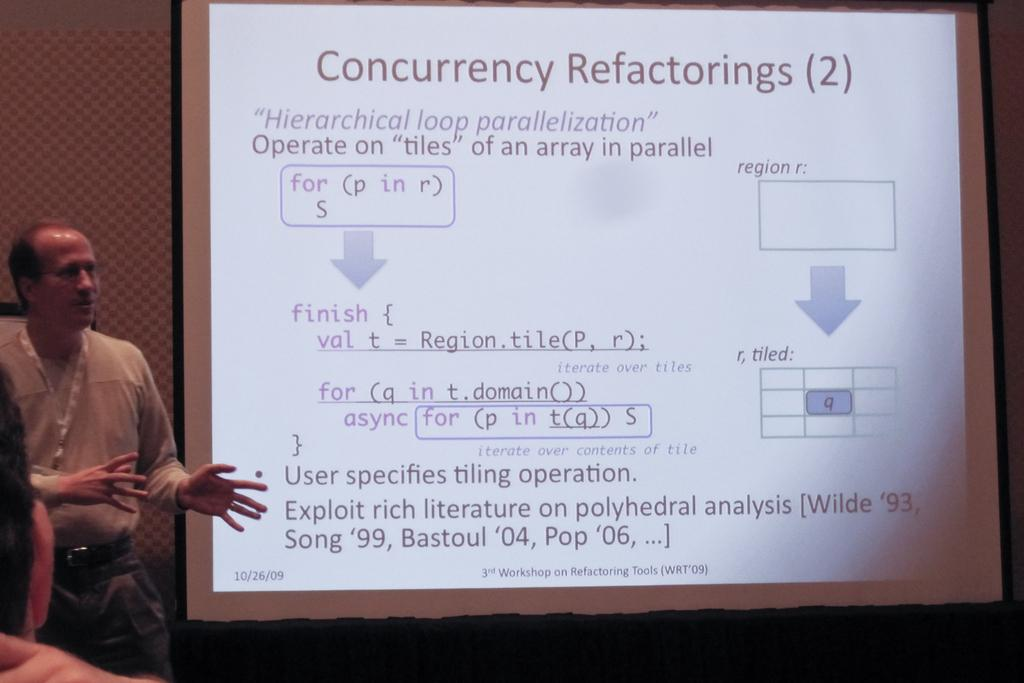What is the main subject of the image? There is a person standing in the image. What else can be seen in the image besides the person? There is a screen with text in the image. Can you describe the position of the second person in the image? There is a person in the bottom left corner of the image. What color is the hen in the image? There is no hen present in the image. What type of vest is the person wearing in the image? There is no vest visible in the image. 